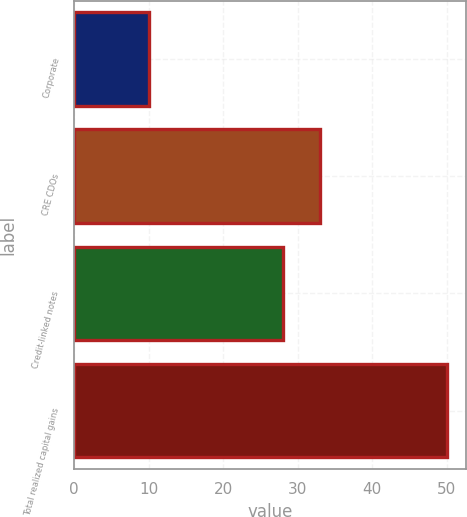Convert chart. <chart><loc_0><loc_0><loc_500><loc_500><bar_chart><fcel>Corporate<fcel>CRE CDOs<fcel>Credit-linked notes<fcel>Total realized capital gains<nl><fcel>10<fcel>33<fcel>28<fcel>50<nl></chart> 